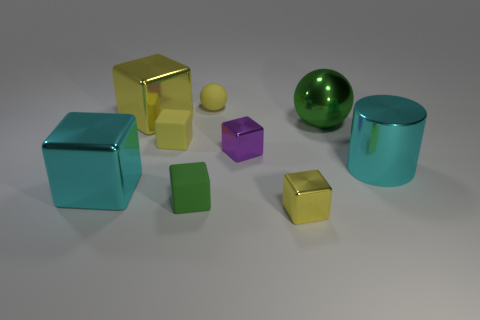There is a big green metal thing; what shape is it?
Your response must be concise. Sphere. Is the number of green metallic spheres that are behind the tiny yellow matte sphere greater than the number of large green balls on the right side of the green sphere?
Keep it short and to the point. No. There is a green object that is to the left of the tiny rubber ball; does it have the same shape as the cyan object that is to the left of the large yellow cube?
Your response must be concise. Yes. How many other things are the same size as the green ball?
Ensure brevity in your answer.  3. What is the size of the cyan block?
Provide a succinct answer. Large. Is the material of the big cyan block left of the big cyan metallic cylinder the same as the purple block?
Make the answer very short. Yes. There is another small shiny object that is the same shape as the small yellow shiny object; what is its color?
Offer a terse response. Purple. Does the small metal object in front of the small green matte cube have the same color as the rubber sphere?
Keep it short and to the point. Yes. There is a large green shiny object; are there any cylinders in front of it?
Make the answer very short. Yes. What color is the large thing that is both in front of the metallic sphere and left of the green metal object?
Offer a very short reply. Cyan. 